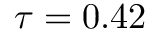<formula> <loc_0><loc_0><loc_500><loc_500>\tau = 0 . 4 2</formula> 